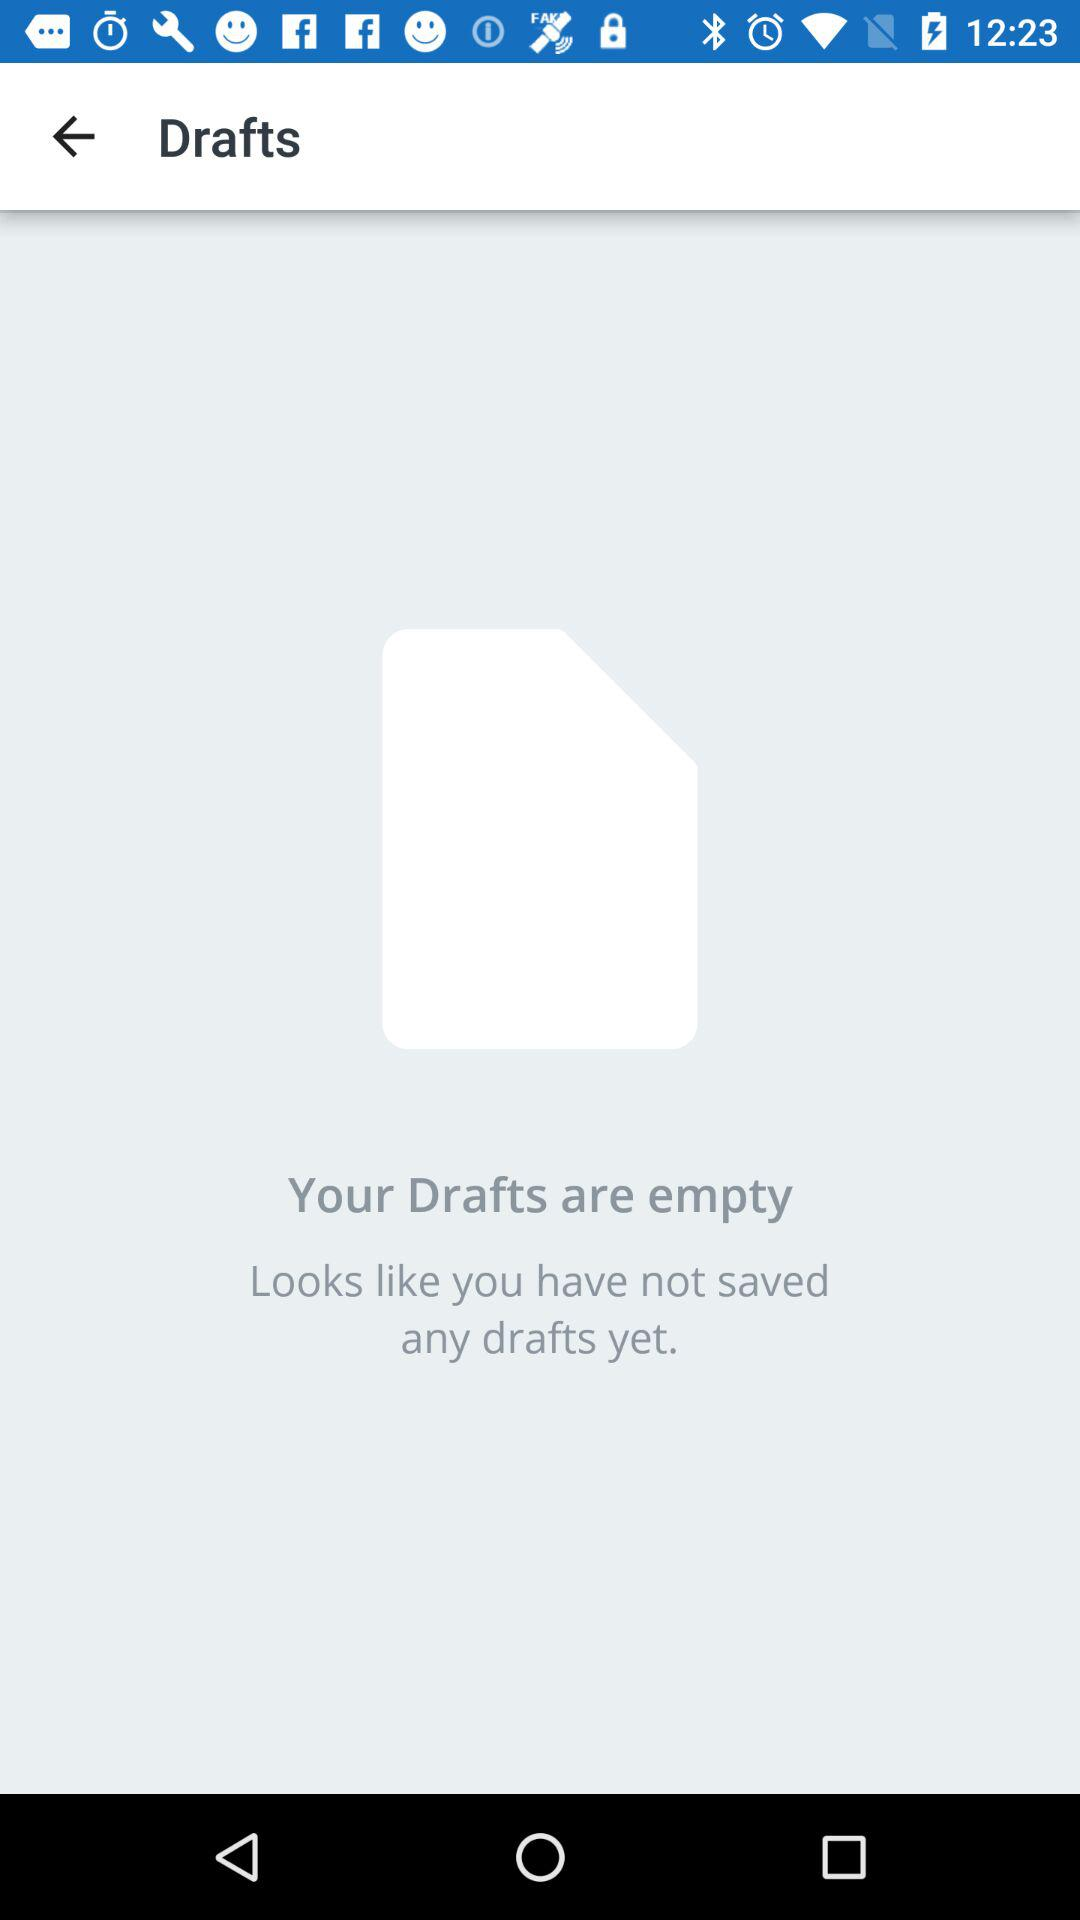How many drafts are saved? There are no drafts saved. 